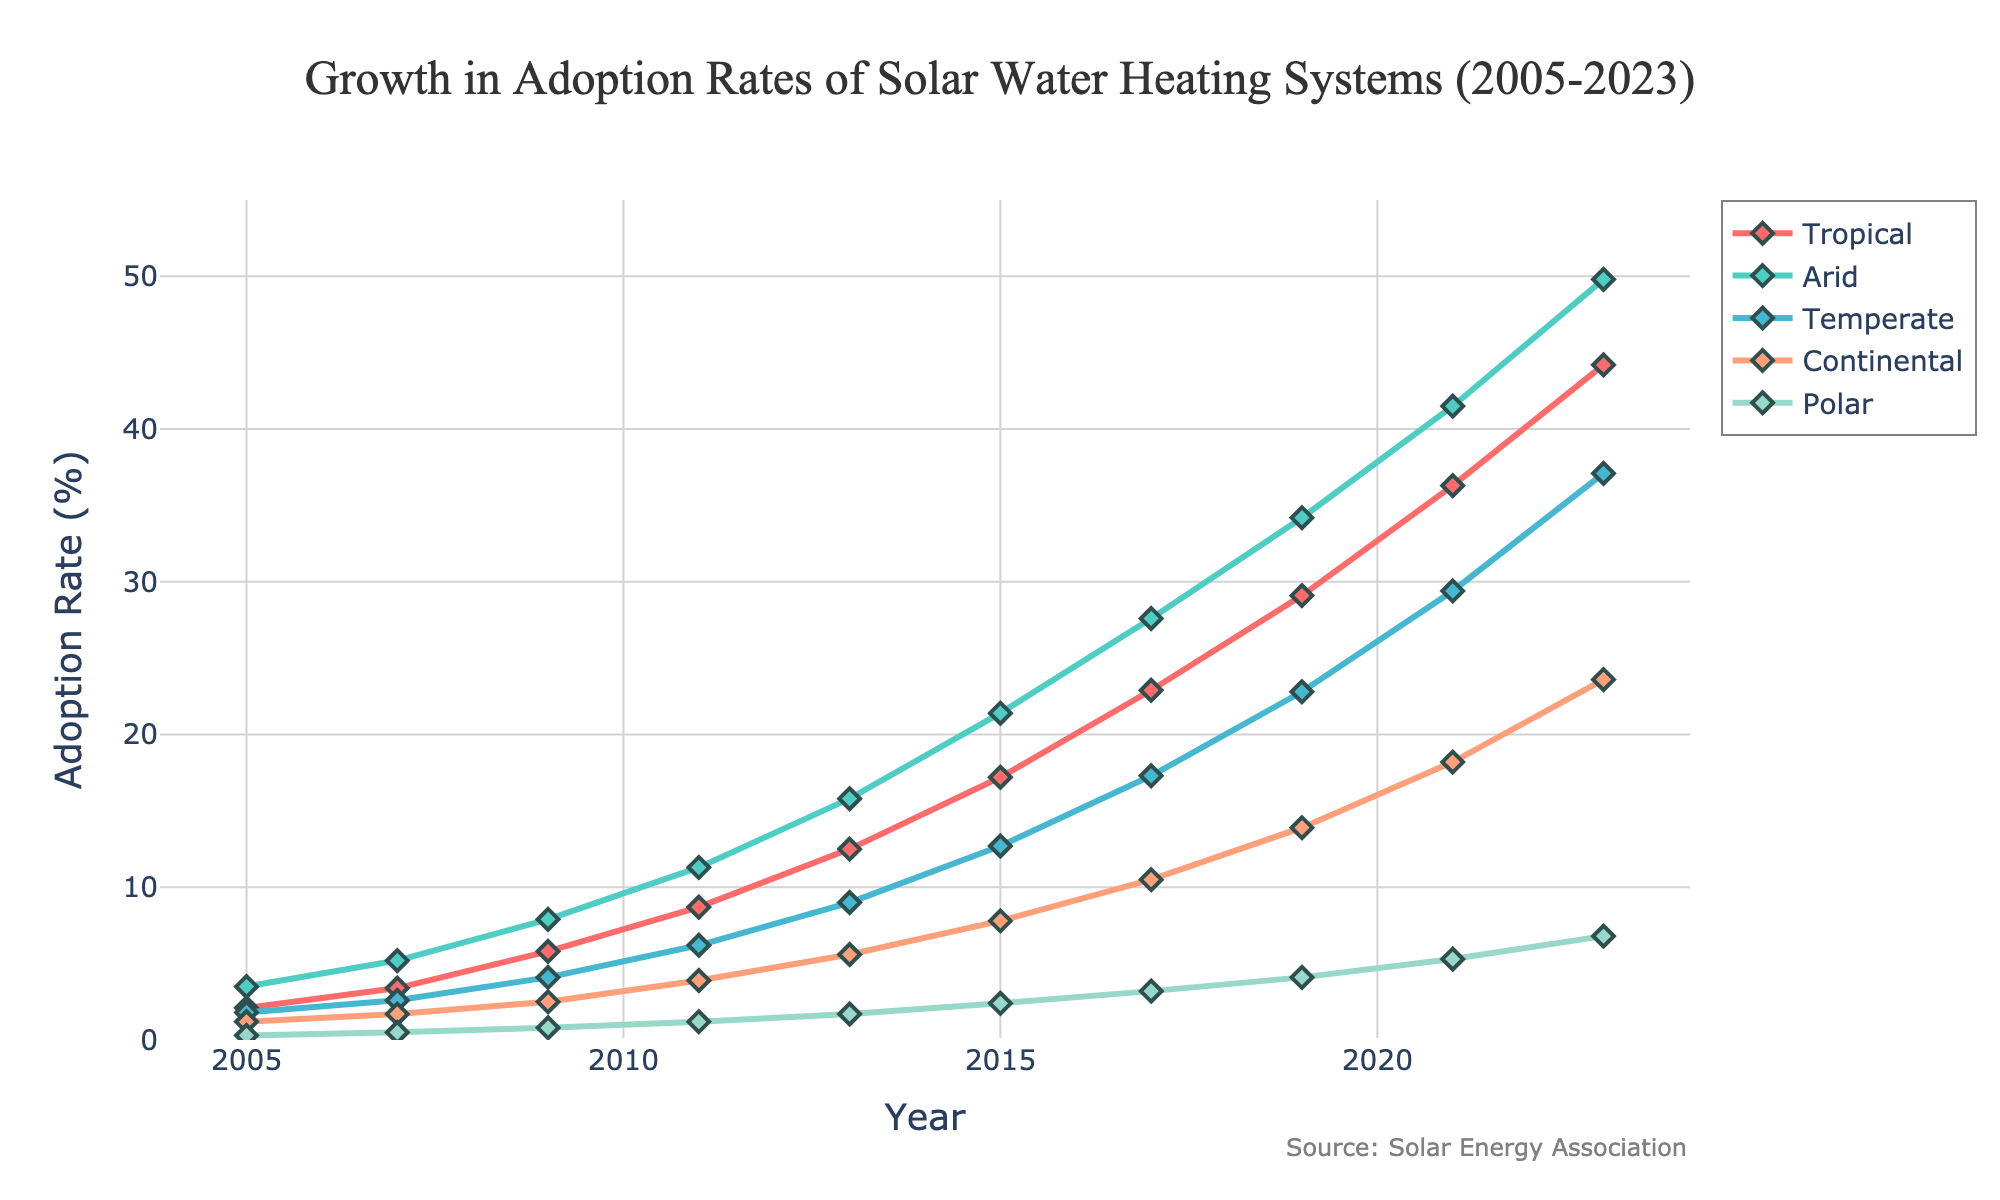What trend can be observed in the adoption rates of solar water heating systems in tropical and polar climate zones from 2005 to 2023? Both the tropical and polar climate zones show an increasing trend in adoption rates from 2005 to 2023, with tropical zones seeing a more significant increase. The adoption rate in tropical zones started at 2.1% in 2005 and rose to 44.2% in 2023, while in polar zones, it went from 0.3% in 2005 to 6.8% in 2023.
Answer: Both are increasing, tropical more significantly Which climate zone had the highest adoption rate by 2013, and what was that rate? By examining the lines on the chart for the year 2013, the arid zone has the highest adoption rate among all the climate zones. The adoption rate for the arid zone in 2013 is plotted at 15.8% on the y-axis.
Answer: Arid, 15.8% How much did the adoption rate of the continental climate zone increase from 2005 to 2023? In 2005, the adoption rate for the continental zone was 1.2%, and in 2023, it was 23.6%. The increase is calculated by subtracting the initial value from the final value (23.6% - 1.2% = 22.4%).
Answer: 22.4% Between 2005 and 2023, which climate zone had the fastest growth in adoption rates? From the chart, comparing the slopes of the lines from 2005 to 2023, the tropical zone shows the fastest growth. Its adoption rate increased from 2.1% in 2005 to 44.2% in 2023, a total increase of 42.1%.
Answer: Tropical In which year did the arid climate zone see an adoption rate crossing 20%? Referring to the chart, the arid climate zone crossed the 20% adoption rate mark between 2013 and 2015. Specifically, it happens in the year 2015, where the rate is plotted at 21.4%.
Answer: 2015 Compare the adoption rates of temperate and continental climate zones in 2021. Which zone had a higher rate, and by how much? In 2021, the adoption rate for the temperate zone is plotted at 29.4%, and for the continental zone, it is 18.2%. The temperate zone is higher by calculating the difference (29.4% - 18.2% = 11.2%).
Answer: Temperate, 11.2% What is the average adoption rate for the temperate zone over the years provided? Adding up the adoption rates for the temperate zone across all the years (1.8 + 2.6 + 4.1 + 6.2 + 9.0 + 12.7 + 17.3 + 22.8 + 29.4 + 37.1) and dividing by the number of years (10), the average is (143.0/10 = 14.3%).
Answer: 14.3% What can be inferred about the relative adoption rates of the polar climate zone compared to other zones? The polar climate zone consistently shows the lowest adoption rates throughout the period. For example, in 2023, its rate is 6.8%, while the next highest rate (continental) is 23.6%. This suggests that the adoption of solar water heating systems is significantly lower in polar regions compared to other climate zones.
Answer: Lowest adoption rate 